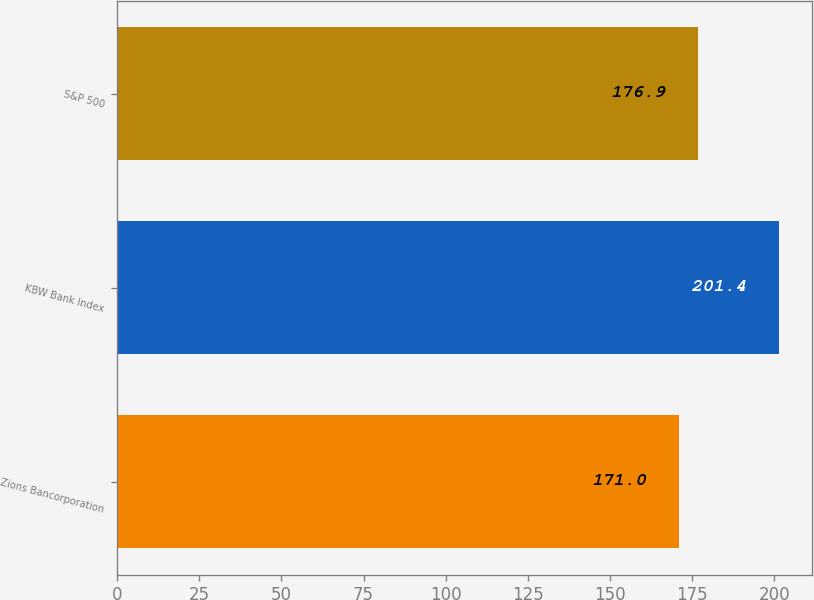Convert chart to OTSL. <chart><loc_0><loc_0><loc_500><loc_500><bar_chart><fcel>Zions Bancorporation<fcel>KBW Bank Index<fcel>S&P 500<nl><fcel>171<fcel>201.4<fcel>176.9<nl></chart> 